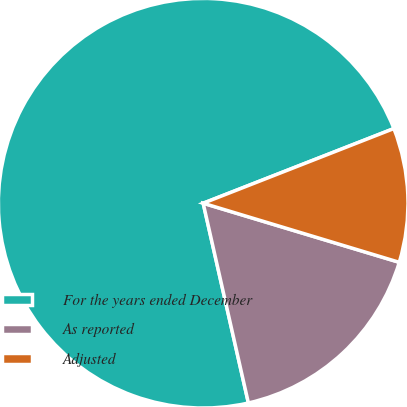Convert chart. <chart><loc_0><loc_0><loc_500><loc_500><pie_chart><fcel>For the years ended December<fcel>As reported<fcel>Adjusted<nl><fcel>72.61%<fcel>16.8%<fcel>10.6%<nl></chart> 